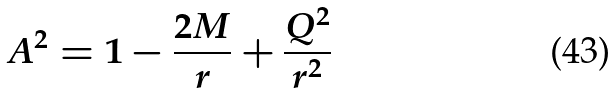<formula> <loc_0><loc_0><loc_500><loc_500>A ^ { 2 } = 1 - \frac { 2 M } { r } + \frac { Q ^ { 2 } } { r ^ { 2 } }</formula> 